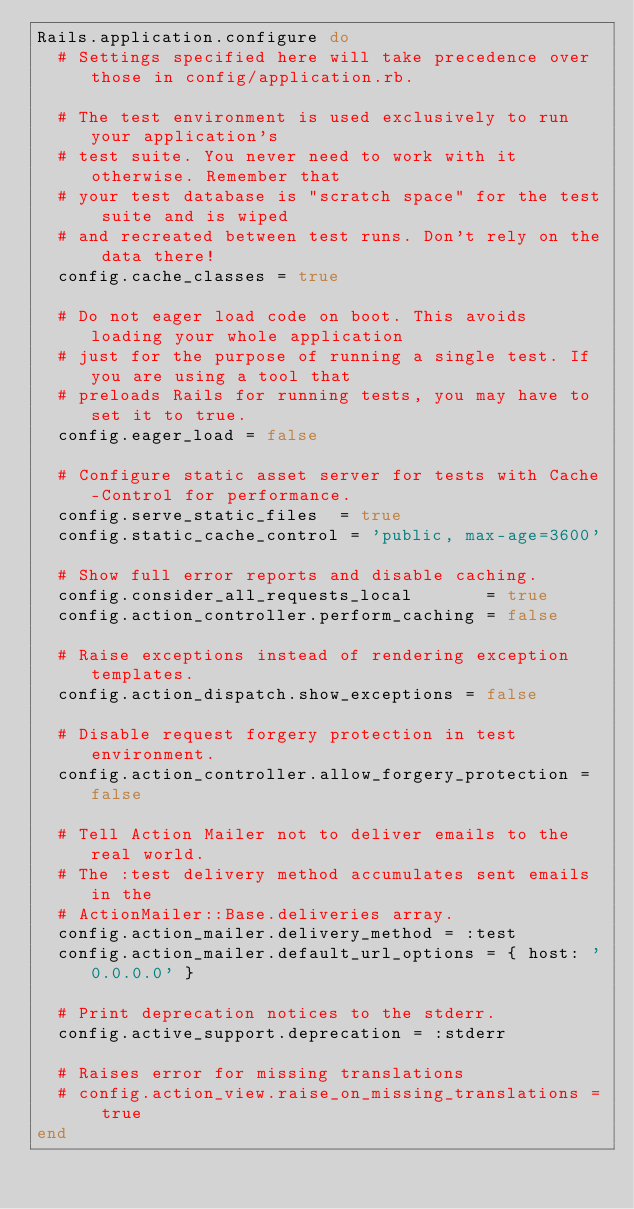<code> <loc_0><loc_0><loc_500><loc_500><_Ruby_>Rails.application.configure do
  # Settings specified here will take precedence over those in config/application.rb.

  # The test environment is used exclusively to run your application's
  # test suite. You never need to work with it otherwise. Remember that
  # your test database is "scratch space" for the test suite and is wiped
  # and recreated between test runs. Don't rely on the data there!
  config.cache_classes = true

  # Do not eager load code on boot. This avoids loading your whole application
  # just for the purpose of running a single test. If you are using a tool that
  # preloads Rails for running tests, you may have to set it to true.
  config.eager_load = false

  # Configure static asset server for tests with Cache-Control for performance.
  config.serve_static_files  = true
  config.static_cache_control = 'public, max-age=3600'

  # Show full error reports and disable caching.
  config.consider_all_requests_local       = true
  config.action_controller.perform_caching = false

  # Raise exceptions instead of rendering exception templates.
  config.action_dispatch.show_exceptions = false

  # Disable request forgery protection in test environment.
  config.action_controller.allow_forgery_protection = false

  # Tell Action Mailer not to deliver emails to the real world.
  # The :test delivery method accumulates sent emails in the
  # ActionMailer::Base.deliveries array.
  config.action_mailer.delivery_method = :test
  config.action_mailer.default_url_options = { host: '0.0.0.0' }

  # Print deprecation notices to the stderr.
  config.active_support.deprecation = :stderr

  # Raises error for missing translations
  # config.action_view.raise_on_missing_translations = true
end
</code> 